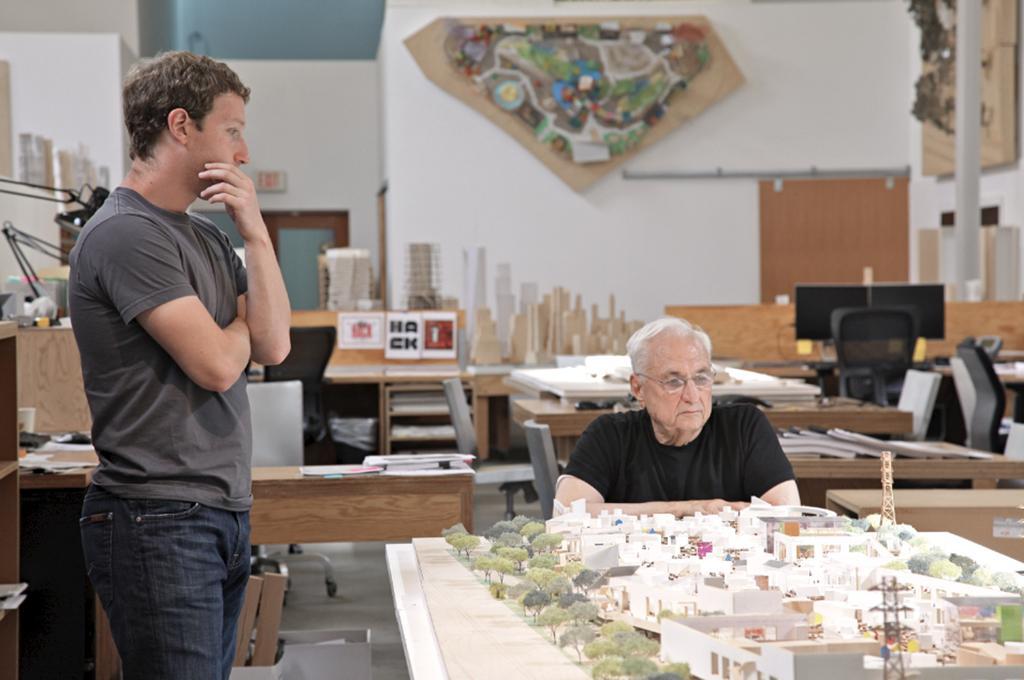In one or two sentences, can you explain what this image depicts? On the right side of the image we can see person sitting at the table. On the table we can see map. On the left side of the image we can see person standing on the floor. In the background we can see tables, monitors, chairs, books, lights, door, wall, map and wall. 